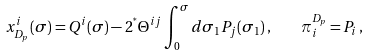Convert formula to latex. <formula><loc_0><loc_0><loc_500><loc_500>x ^ { i } _ { D _ { p } } ( \sigma ) = Q ^ { i } ( \sigma ) - 2 ^ { ^ { * } } \Theta ^ { i j } \int ^ { \sigma } _ { 0 } d \sigma _ { 1 } P _ { j } ( \sigma _ { 1 } ) \, , \quad \pi _ { i } ^ { D _ { p } } = P _ { i } \, ,</formula> 